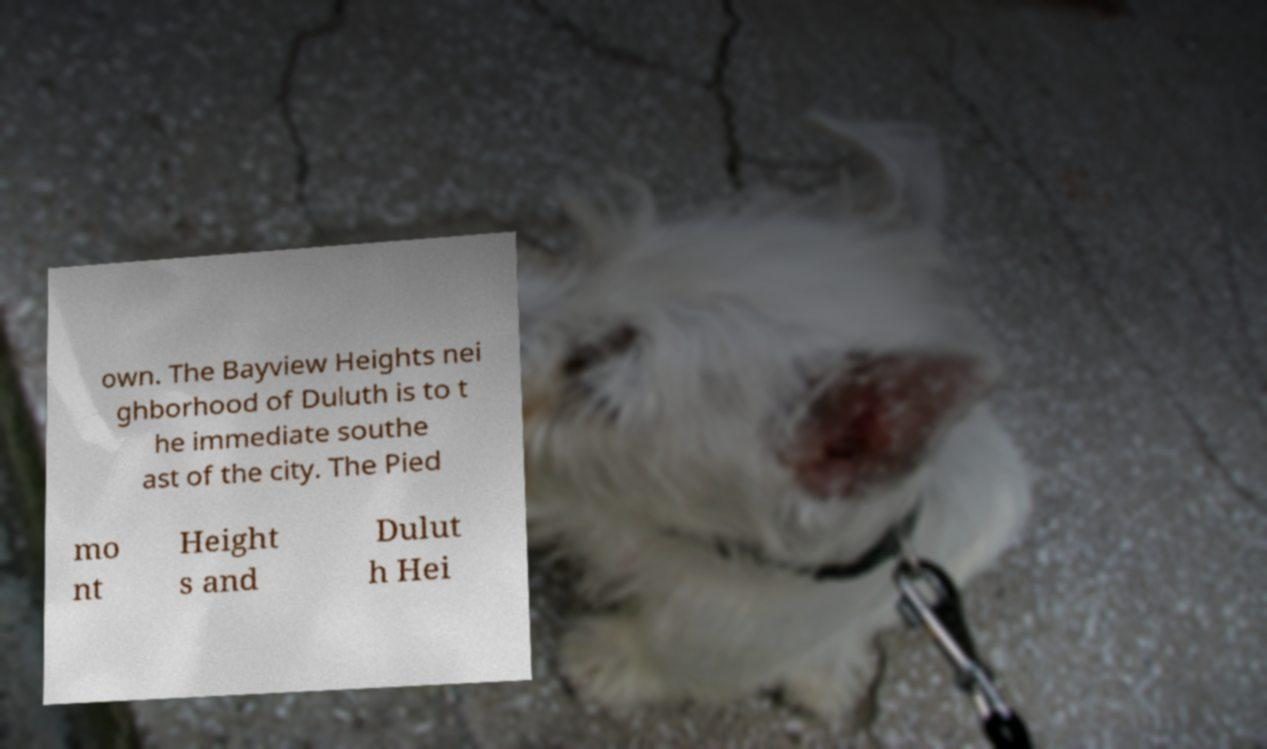Could you assist in decoding the text presented in this image and type it out clearly? own. The Bayview Heights nei ghborhood of Duluth is to t he immediate southe ast of the city. The Pied mo nt Height s and Dulut h Hei 